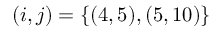<formula> <loc_0><loc_0><loc_500><loc_500>( i , j ) = \{ ( 4 , 5 ) , ( 5 , 1 0 ) \}</formula> 